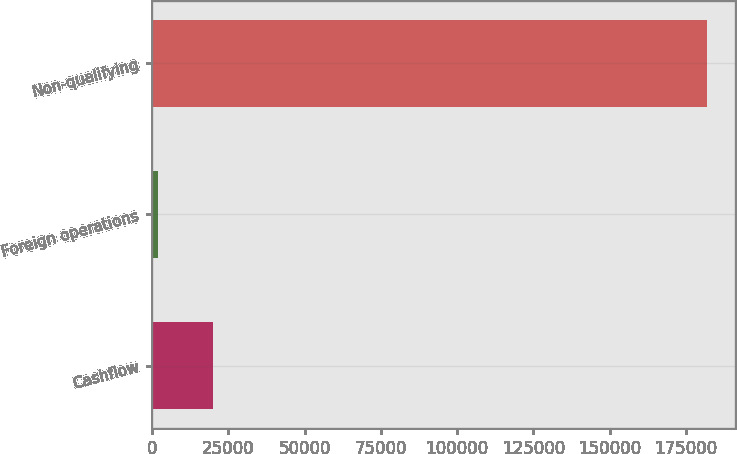<chart> <loc_0><loc_0><loc_500><loc_500><bar_chart><fcel>Cashflow<fcel>Foreign operations<fcel>Non-qualifying<nl><fcel>19845.8<fcel>1834<fcel>181952<nl></chart> 